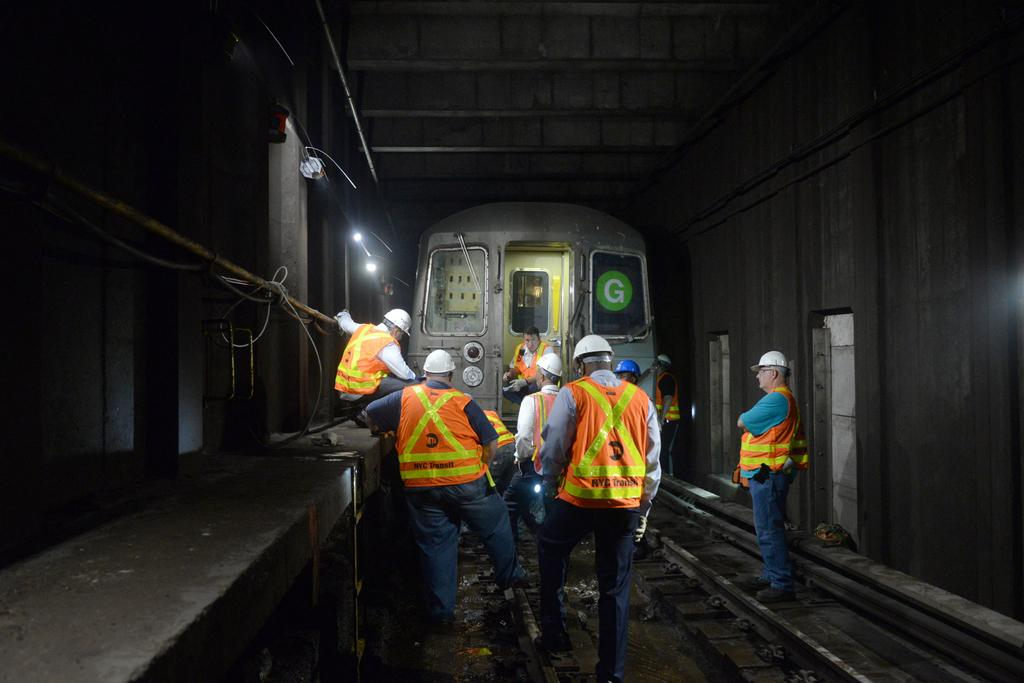What type of transportation can be seen in the image? There is a train in the image. What is the train traveling on? The train is traveling on railway tracks. What additional features can be seen in the image? There are lights, wires, a pipe, and text visible in the image. What safety precaution are most people taking in the image? Most people are wearing helmets. Can you describe the detail of the tramp in the image? There is no tramp present in the image. What type of owl can be seen perched on the train in the image? There is no owl present in the image. 